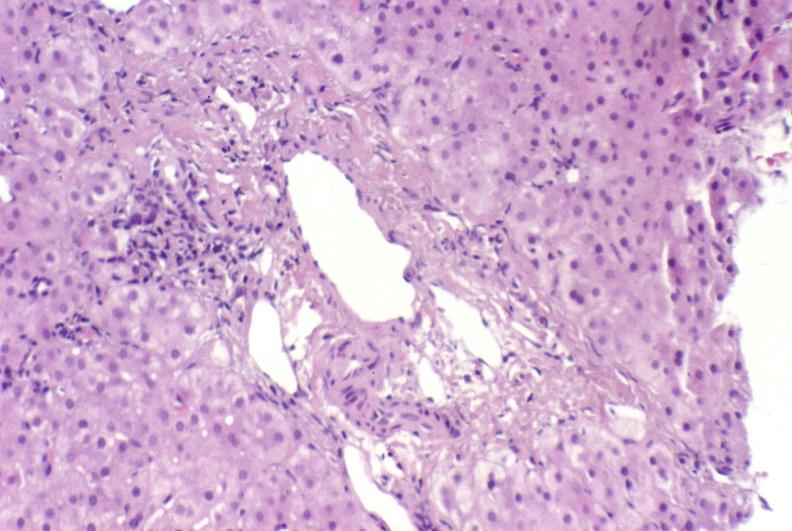s hepatobiliary present?
Answer the question using a single word or phrase. Yes 